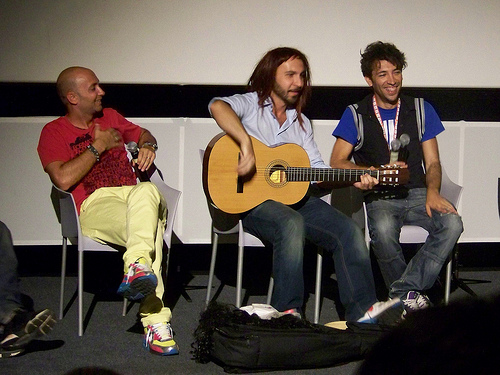<image>
Is the guitar on the man? No. The guitar is not positioned on the man. They may be near each other, but the guitar is not supported by or resting on top of the man. Where is the guitar in relation to the man? Is it on the man? No. The guitar is not positioned on the man. They may be near each other, but the guitar is not supported by or resting on top of the man. Is there a man on the guitar? No. The man is not positioned on the guitar. They may be near each other, but the man is not supported by or resting on top of the guitar. Is there a man behind the chair? No. The man is not behind the chair. From this viewpoint, the man appears to be positioned elsewhere in the scene. Is the man in front of the guitar? No. The man is not in front of the guitar. The spatial positioning shows a different relationship between these objects. Is there a man in front of the bag? No. The man is not in front of the bag. The spatial positioning shows a different relationship between these objects. 